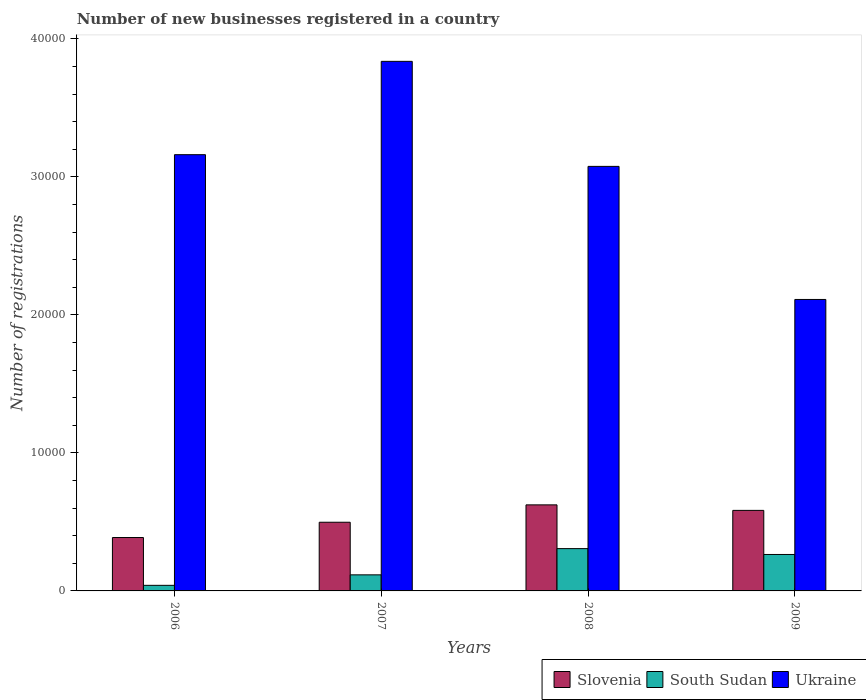Are the number of bars on each tick of the X-axis equal?
Provide a succinct answer. Yes. How many bars are there on the 2nd tick from the left?
Make the answer very short. 3. What is the label of the 4th group of bars from the left?
Your response must be concise. 2009. What is the number of new businesses registered in South Sudan in 2009?
Provide a succinct answer. 2641. Across all years, what is the maximum number of new businesses registered in Slovenia?
Keep it short and to the point. 6235. Across all years, what is the minimum number of new businesses registered in Slovenia?
Give a very brief answer. 3869. In which year was the number of new businesses registered in Slovenia minimum?
Provide a succinct answer. 2006. What is the total number of new businesses registered in South Sudan in the graph?
Your answer should be compact. 7275. What is the difference between the number of new businesses registered in South Sudan in 2006 and that in 2007?
Make the answer very short. -759. What is the difference between the number of new businesses registered in Ukraine in 2007 and the number of new businesses registered in South Sudan in 2008?
Provide a succinct answer. 3.53e+04. What is the average number of new businesses registered in South Sudan per year?
Offer a terse response. 1818.75. In the year 2006, what is the difference between the number of new businesses registered in South Sudan and number of new businesses registered in Slovenia?
Your response must be concise. -3464. In how many years, is the number of new businesses registered in Slovenia greater than 2000?
Make the answer very short. 4. What is the ratio of the number of new businesses registered in Slovenia in 2006 to that in 2008?
Provide a short and direct response. 0.62. Is the number of new businesses registered in Ukraine in 2008 less than that in 2009?
Your answer should be compact. No. Is the difference between the number of new businesses registered in South Sudan in 2007 and 2008 greater than the difference between the number of new businesses registered in Slovenia in 2007 and 2008?
Give a very brief answer. No. What is the difference between the highest and the second highest number of new businesses registered in Ukraine?
Offer a terse response. 6762. What is the difference between the highest and the lowest number of new businesses registered in Ukraine?
Your answer should be compact. 1.73e+04. Is the sum of the number of new businesses registered in South Sudan in 2006 and 2007 greater than the maximum number of new businesses registered in Ukraine across all years?
Your answer should be very brief. No. What does the 3rd bar from the left in 2006 represents?
Give a very brief answer. Ukraine. What does the 3rd bar from the right in 2006 represents?
Make the answer very short. Slovenia. Are all the bars in the graph horizontal?
Your response must be concise. No. How many years are there in the graph?
Provide a succinct answer. 4. What is the difference between two consecutive major ticks on the Y-axis?
Offer a terse response. 10000. Does the graph contain any zero values?
Offer a terse response. No. Does the graph contain grids?
Keep it short and to the point. No. Where does the legend appear in the graph?
Offer a very short reply. Bottom right. What is the title of the graph?
Your answer should be very brief. Number of new businesses registered in a country. What is the label or title of the Y-axis?
Your answer should be very brief. Number of registrations. What is the Number of registrations in Slovenia in 2006?
Your answer should be compact. 3869. What is the Number of registrations in South Sudan in 2006?
Ensure brevity in your answer.  405. What is the Number of registrations in Ukraine in 2006?
Provide a short and direct response. 3.16e+04. What is the Number of registrations of Slovenia in 2007?
Your answer should be very brief. 4976. What is the Number of registrations in South Sudan in 2007?
Keep it short and to the point. 1164. What is the Number of registrations in Ukraine in 2007?
Provide a short and direct response. 3.84e+04. What is the Number of registrations in Slovenia in 2008?
Provide a short and direct response. 6235. What is the Number of registrations in South Sudan in 2008?
Offer a terse response. 3065. What is the Number of registrations in Ukraine in 2008?
Your answer should be compact. 3.08e+04. What is the Number of registrations in Slovenia in 2009?
Your response must be concise. 5836. What is the Number of registrations in South Sudan in 2009?
Offer a terse response. 2641. What is the Number of registrations of Ukraine in 2009?
Provide a short and direct response. 2.11e+04. Across all years, what is the maximum Number of registrations in Slovenia?
Ensure brevity in your answer.  6235. Across all years, what is the maximum Number of registrations of South Sudan?
Your answer should be very brief. 3065. Across all years, what is the maximum Number of registrations of Ukraine?
Keep it short and to the point. 3.84e+04. Across all years, what is the minimum Number of registrations of Slovenia?
Your answer should be very brief. 3869. Across all years, what is the minimum Number of registrations in South Sudan?
Give a very brief answer. 405. Across all years, what is the minimum Number of registrations in Ukraine?
Provide a short and direct response. 2.11e+04. What is the total Number of registrations of Slovenia in the graph?
Your answer should be compact. 2.09e+04. What is the total Number of registrations of South Sudan in the graph?
Your response must be concise. 7275. What is the total Number of registrations of Ukraine in the graph?
Offer a very short reply. 1.22e+05. What is the difference between the Number of registrations of Slovenia in 2006 and that in 2007?
Ensure brevity in your answer.  -1107. What is the difference between the Number of registrations in South Sudan in 2006 and that in 2007?
Make the answer very short. -759. What is the difference between the Number of registrations of Ukraine in 2006 and that in 2007?
Offer a terse response. -6762. What is the difference between the Number of registrations of Slovenia in 2006 and that in 2008?
Your response must be concise. -2366. What is the difference between the Number of registrations of South Sudan in 2006 and that in 2008?
Ensure brevity in your answer.  -2660. What is the difference between the Number of registrations of Ukraine in 2006 and that in 2008?
Your answer should be very brief. 849. What is the difference between the Number of registrations of Slovenia in 2006 and that in 2009?
Your answer should be compact. -1967. What is the difference between the Number of registrations in South Sudan in 2006 and that in 2009?
Your response must be concise. -2236. What is the difference between the Number of registrations of Ukraine in 2006 and that in 2009?
Your answer should be compact. 1.05e+04. What is the difference between the Number of registrations of Slovenia in 2007 and that in 2008?
Offer a terse response. -1259. What is the difference between the Number of registrations of South Sudan in 2007 and that in 2008?
Offer a terse response. -1901. What is the difference between the Number of registrations of Ukraine in 2007 and that in 2008?
Your response must be concise. 7611. What is the difference between the Number of registrations in Slovenia in 2007 and that in 2009?
Offer a terse response. -860. What is the difference between the Number of registrations of South Sudan in 2007 and that in 2009?
Offer a terse response. -1477. What is the difference between the Number of registrations in Ukraine in 2007 and that in 2009?
Your answer should be compact. 1.73e+04. What is the difference between the Number of registrations of Slovenia in 2008 and that in 2009?
Your answer should be compact. 399. What is the difference between the Number of registrations of South Sudan in 2008 and that in 2009?
Make the answer very short. 424. What is the difference between the Number of registrations in Ukraine in 2008 and that in 2009?
Your answer should be very brief. 9642. What is the difference between the Number of registrations of Slovenia in 2006 and the Number of registrations of South Sudan in 2007?
Provide a short and direct response. 2705. What is the difference between the Number of registrations of Slovenia in 2006 and the Number of registrations of Ukraine in 2007?
Make the answer very short. -3.45e+04. What is the difference between the Number of registrations in South Sudan in 2006 and the Number of registrations in Ukraine in 2007?
Offer a terse response. -3.80e+04. What is the difference between the Number of registrations in Slovenia in 2006 and the Number of registrations in South Sudan in 2008?
Offer a terse response. 804. What is the difference between the Number of registrations of Slovenia in 2006 and the Number of registrations of Ukraine in 2008?
Your response must be concise. -2.69e+04. What is the difference between the Number of registrations in South Sudan in 2006 and the Number of registrations in Ukraine in 2008?
Your answer should be compact. -3.04e+04. What is the difference between the Number of registrations of Slovenia in 2006 and the Number of registrations of South Sudan in 2009?
Offer a terse response. 1228. What is the difference between the Number of registrations of Slovenia in 2006 and the Number of registrations of Ukraine in 2009?
Your response must be concise. -1.73e+04. What is the difference between the Number of registrations of South Sudan in 2006 and the Number of registrations of Ukraine in 2009?
Offer a very short reply. -2.07e+04. What is the difference between the Number of registrations of Slovenia in 2007 and the Number of registrations of South Sudan in 2008?
Keep it short and to the point. 1911. What is the difference between the Number of registrations in Slovenia in 2007 and the Number of registrations in Ukraine in 2008?
Keep it short and to the point. -2.58e+04. What is the difference between the Number of registrations of South Sudan in 2007 and the Number of registrations of Ukraine in 2008?
Ensure brevity in your answer.  -2.96e+04. What is the difference between the Number of registrations in Slovenia in 2007 and the Number of registrations in South Sudan in 2009?
Your answer should be compact. 2335. What is the difference between the Number of registrations of Slovenia in 2007 and the Number of registrations of Ukraine in 2009?
Give a very brief answer. -1.61e+04. What is the difference between the Number of registrations of South Sudan in 2007 and the Number of registrations of Ukraine in 2009?
Keep it short and to the point. -2.00e+04. What is the difference between the Number of registrations in Slovenia in 2008 and the Number of registrations in South Sudan in 2009?
Your response must be concise. 3594. What is the difference between the Number of registrations of Slovenia in 2008 and the Number of registrations of Ukraine in 2009?
Give a very brief answer. -1.49e+04. What is the difference between the Number of registrations in South Sudan in 2008 and the Number of registrations in Ukraine in 2009?
Your answer should be very brief. -1.81e+04. What is the average Number of registrations in Slovenia per year?
Give a very brief answer. 5229. What is the average Number of registrations of South Sudan per year?
Ensure brevity in your answer.  1818.75. What is the average Number of registrations of Ukraine per year?
Your response must be concise. 3.05e+04. In the year 2006, what is the difference between the Number of registrations of Slovenia and Number of registrations of South Sudan?
Your answer should be compact. 3464. In the year 2006, what is the difference between the Number of registrations of Slovenia and Number of registrations of Ukraine?
Give a very brief answer. -2.77e+04. In the year 2006, what is the difference between the Number of registrations in South Sudan and Number of registrations in Ukraine?
Offer a very short reply. -3.12e+04. In the year 2007, what is the difference between the Number of registrations of Slovenia and Number of registrations of South Sudan?
Offer a terse response. 3812. In the year 2007, what is the difference between the Number of registrations of Slovenia and Number of registrations of Ukraine?
Keep it short and to the point. -3.34e+04. In the year 2007, what is the difference between the Number of registrations of South Sudan and Number of registrations of Ukraine?
Your answer should be compact. -3.72e+04. In the year 2008, what is the difference between the Number of registrations of Slovenia and Number of registrations of South Sudan?
Your answer should be very brief. 3170. In the year 2008, what is the difference between the Number of registrations in Slovenia and Number of registrations in Ukraine?
Ensure brevity in your answer.  -2.45e+04. In the year 2008, what is the difference between the Number of registrations in South Sudan and Number of registrations in Ukraine?
Offer a terse response. -2.77e+04. In the year 2009, what is the difference between the Number of registrations of Slovenia and Number of registrations of South Sudan?
Make the answer very short. 3195. In the year 2009, what is the difference between the Number of registrations of Slovenia and Number of registrations of Ukraine?
Provide a succinct answer. -1.53e+04. In the year 2009, what is the difference between the Number of registrations in South Sudan and Number of registrations in Ukraine?
Make the answer very short. -1.85e+04. What is the ratio of the Number of registrations in Slovenia in 2006 to that in 2007?
Give a very brief answer. 0.78. What is the ratio of the Number of registrations in South Sudan in 2006 to that in 2007?
Provide a succinct answer. 0.35. What is the ratio of the Number of registrations of Ukraine in 2006 to that in 2007?
Your answer should be very brief. 0.82. What is the ratio of the Number of registrations in Slovenia in 2006 to that in 2008?
Provide a succinct answer. 0.62. What is the ratio of the Number of registrations of South Sudan in 2006 to that in 2008?
Offer a very short reply. 0.13. What is the ratio of the Number of registrations in Ukraine in 2006 to that in 2008?
Give a very brief answer. 1.03. What is the ratio of the Number of registrations of Slovenia in 2006 to that in 2009?
Provide a short and direct response. 0.66. What is the ratio of the Number of registrations in South Sudan in 2006 to that in 2009?
Your answer should be very brief. 0.15. What is the ratio of the Number of registrations of Ukraine in 2006 to that in 2009?
Offer a very short reply. 1.5. What is the ratio of the Number of registrations of Slovenia in 2007 to that in 2008?
Make the answer very short. 0.8. What is the ratio of the Number of registrations in South Sudan in 2007 to that in 2008?
Your response must be concise. 0.38. What is the ratio of the Number of registrations in Ukraine in 2007 to that in 2008?
Keep it short and to the point. 1.25. What is the ratio of the Number of registrations of Slovenia in 2007 to that in 2009?
Give a very brief answer. 0.85. What is the ratio of the Number of registrations in South Sudan in 2007 to that in 2009?
Your answer should be very brief. 0.44. What is the ratio of the Number of registrations of Ukraine in 2007 to that in 2009?
Provide a succinct answer. 1.82. What is the ratio of the Number of registrations in Slovenia in 2008 to that in 2009?
Your answer should be very brief. 1.07. What is the ratio of the Number of registrations of South Sudan in 2008 to that in 2009?
Your answer should be compact. 1.16. What is the ratio of the Number of registrations of Ukraine in 2008 to that in 2009?
Provide a succinct answer. 1.46. What is the difference between the highest and the second highest Number of registrations of Slovenia?
Provide a short and direct response. 399. What is the difference between the highest and the second highest Number of registrations of South Sudan?
Ensure brevity in your answer.  424. What is the difference between the highest and the second highest Number of registrations in Ukraine?
Make the answer very short. 6762. What is the difference between the highest and the lowest Number of registrations in Slovenia?
Keep it short and to the point. 2366. What is the difference between the highest and the lowest Number of registrations in South Sudan?
Provide a succinct answer. 2660. What is the difference between the highest and the lowest Number of registrations of Ukraine?
Offer a terse response. 1.73e+04. 